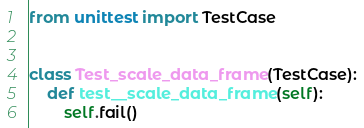<code> <loc_0><loc_0><loc_500><loc_500><_Python_>from unittest import TestCase


class Test_scale_data_frame(TestCase):
    def test__scale_data_frame(self):
        self.fail()
</code> 